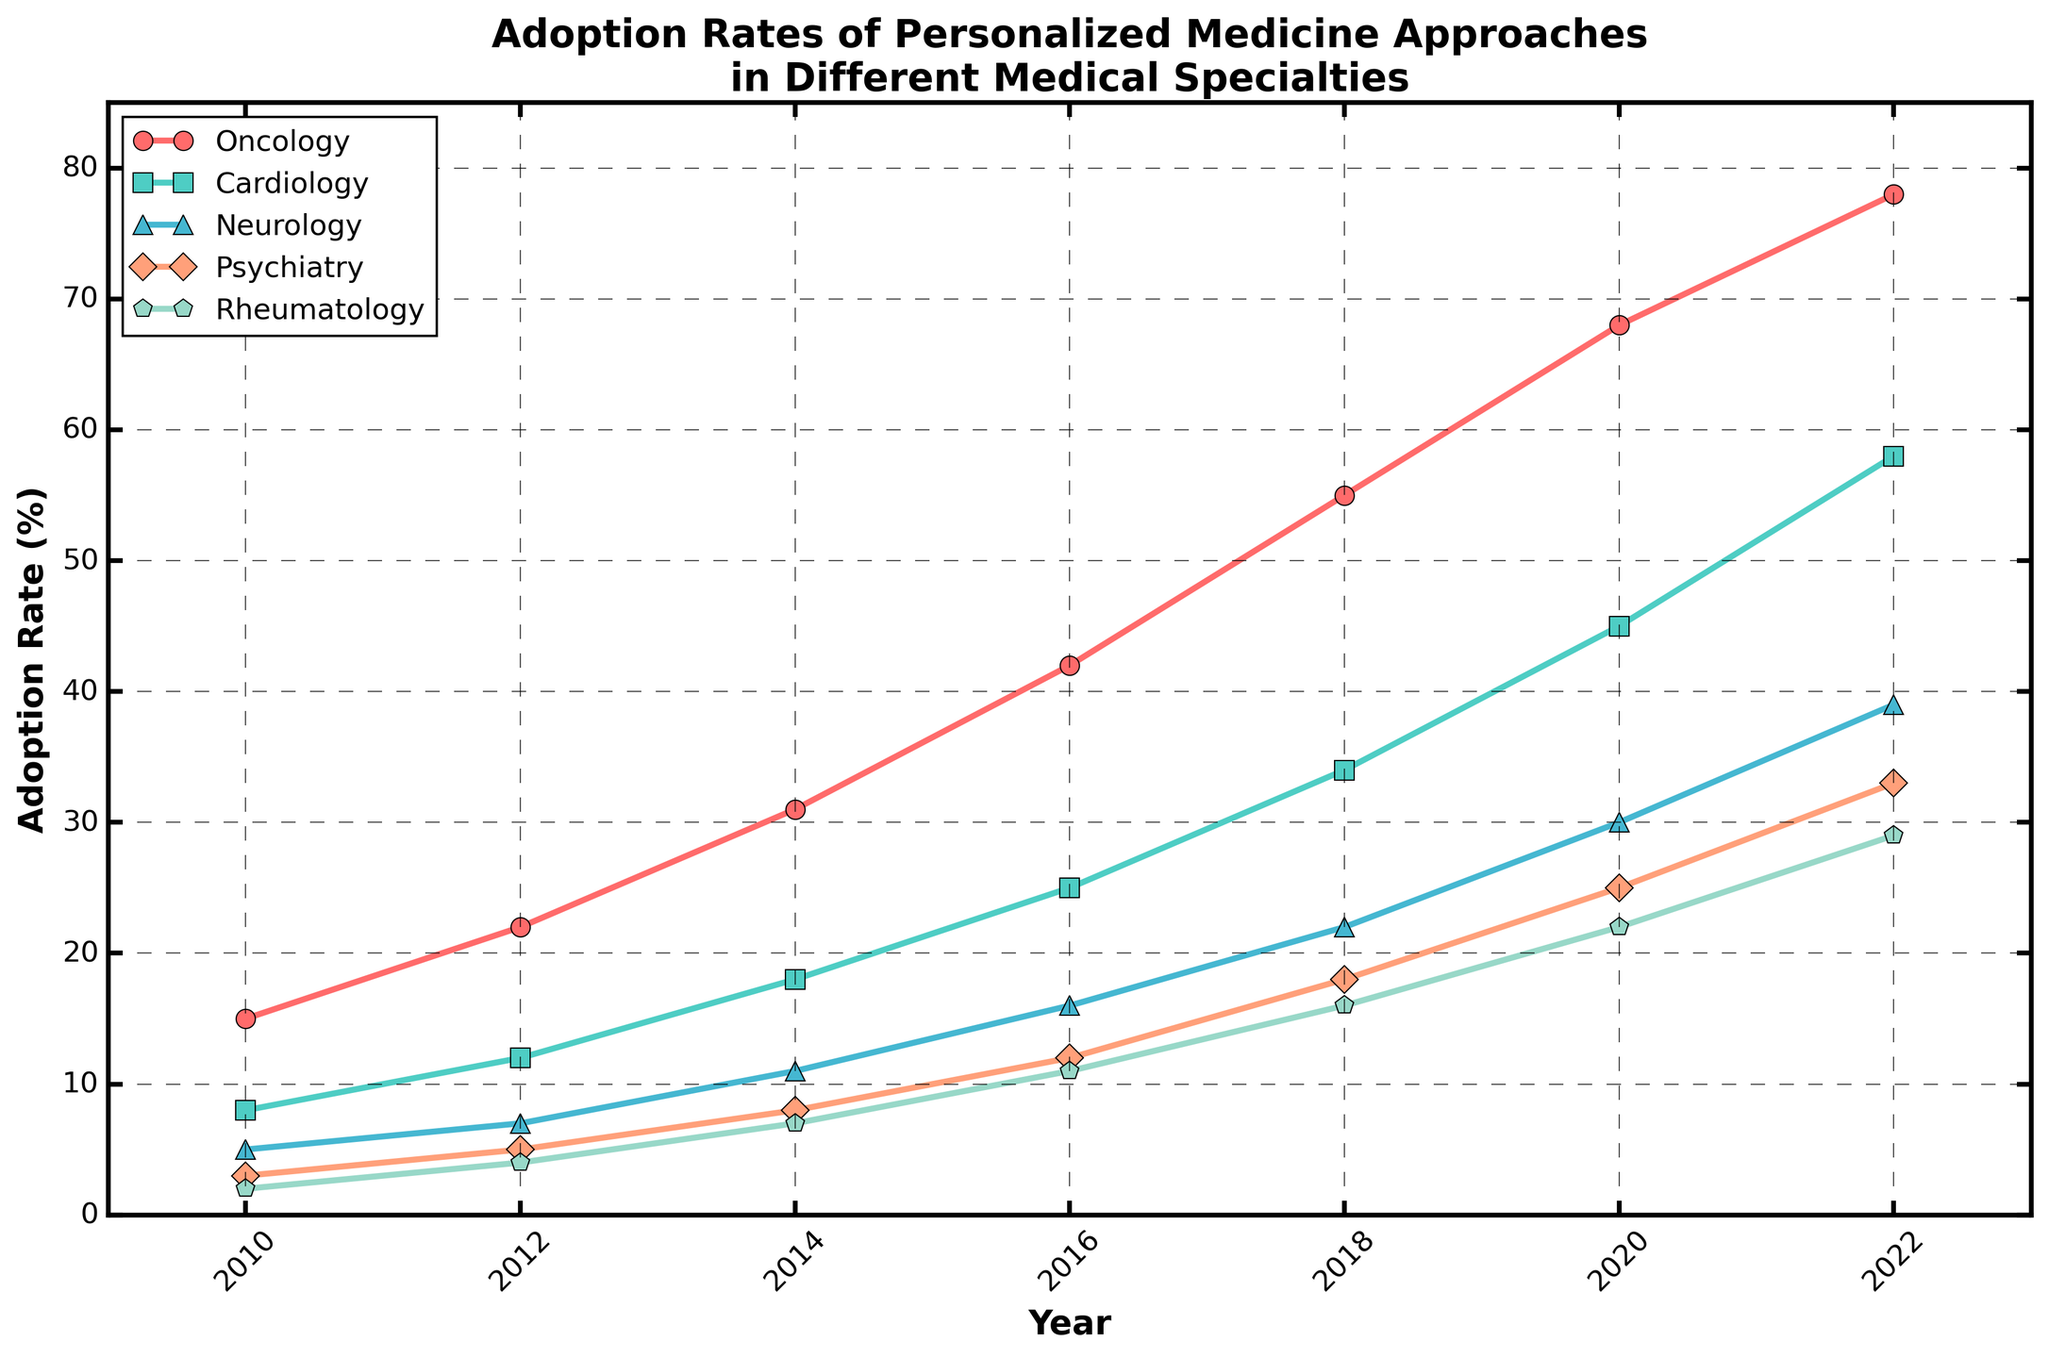What's the highest adoption rate observed in 2022? The line chart shows the adoption rates for different medical specialties over the years. In 2022, Oncology has the highest adoption rate of 78%.
Answer: 78% Which specialty had the lowest adoption rate in 2010 and what is the rate? In the 2010 data, Rheumatology had the lowest adoption rate, which is 2%.
Answer: Rheumatology, 2% Which medical specialty had the fastest growth in adoption rates from 2010 to 2022? To determine this, we calculate the change in adoption rates for each specialty from 2010 to 2022. Oncology's adoption rate increased from 15% in 2010 to 78% in 2022, a change of 63 percentage points, which is the highest among the specialties.
Answer: Oncology By how many percentage points did the adoption rate in Neurology increase from 2014 to 2020? In 2014, the Neurology adoption rate was 11%, and in 2020 it was 30%. The increase is 30% - 11% = 19 percentage points.
Answer: 19 percentage points In which year did Cardiology surpass a 50% adoption rate? Reviewing the line plot, Cardiology surpassed 50% in the year 2022.
Answer: 2022 What is the average adoption rate of Psychiatry in 2018? Since there is only one adoption rate value for Psychiatry in 2018, which is 18%, the average is simply 18%.
Answer: 18% Which specialty showed a higher increase in adoption rate between 2016 and 2020: Psychiatry or Rheumatology? From 2016 to 2020, Psychiatry went from 12% to 25%, which is an increase of 13 percentage points. Rheumatology went from 11% to 22%, an increase of 11 percentage points. Psychiatry had a higher increase.
Answer: Psychiatry In 2020, which specialty had an adoption rate closer to Neurology’s adoption rate? In 2020, Neurology's adoption rate was 30%. Rheumatology had an adoption rate of 22%, while Psychiatry had an adoption rate of 25%. Since 25% is closer to 30% than 22%, Psychiatry is the closer one.
Answer: Psychiatry Which color represents Rheumatology in the plot? The line representing Rheumatology is indicated with a light green color in the chart.
Answer: light green 